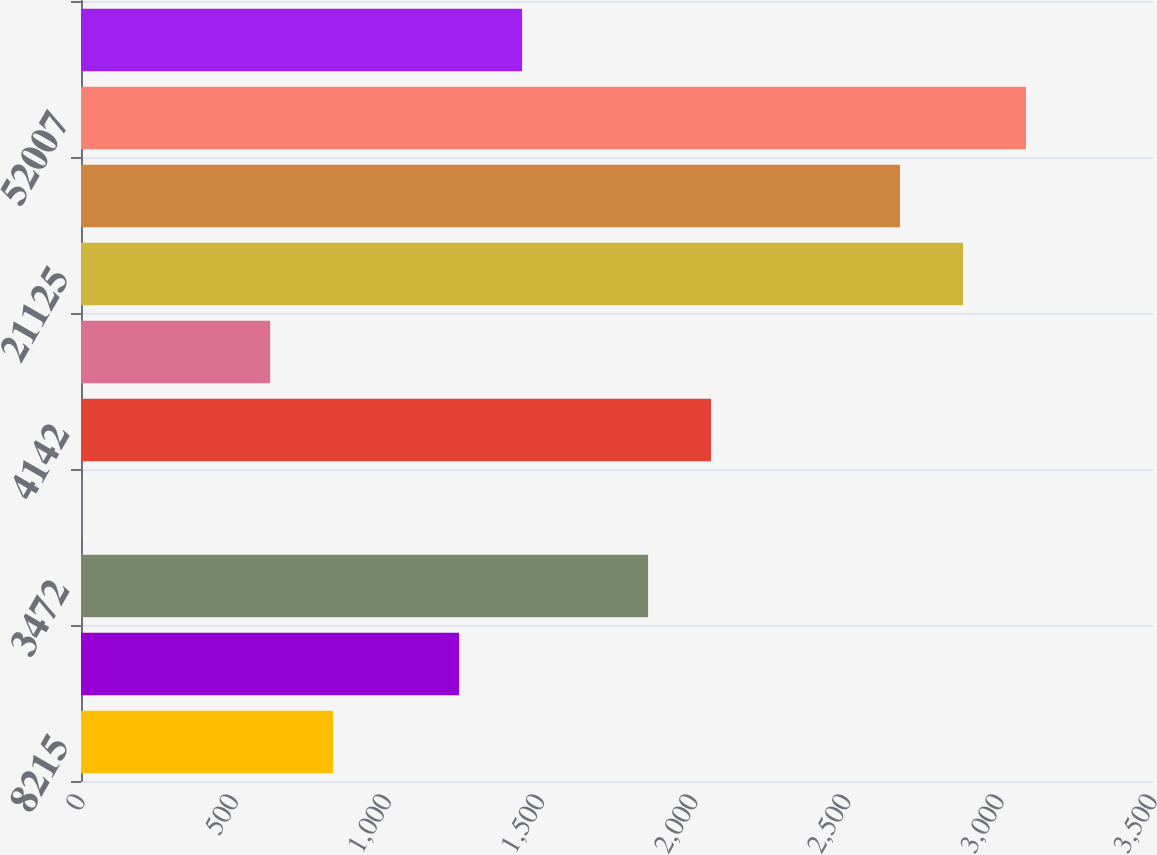Convert chart. <chart><loc_0><loc_0><loc_500><loc_500><bar_chart><fcel>8215<fcel>609<fcel>3472<fcel>61<fcel>4142<fcel>128<fcel>21125<fcel>10337<fcel>52007<fcel>23532<nl><fcel>823.26<fcel>1234.54<fcel>1851.46<fcel>0.7<fcel>2057.1<fcel>617.62<fcel>2879.66<fcel>2674.02<fcel>3085.3<fcel>1440.18<nl></chart> 